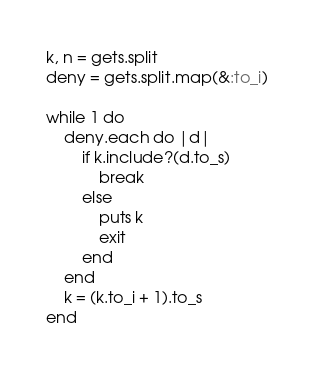Convert code to text. <code><loc_0><loc_0><loc_500><loc_500><_Ruby_>k, n = gets.split
deny = gets.split.map(&:to_i)

while 1 do
	deny.each do |d|
		if k.include?(d.to_s)
			break
		else
			puts k
			exit
		end
	end
	k = (k.to_i + 1).to_s
end</code> 